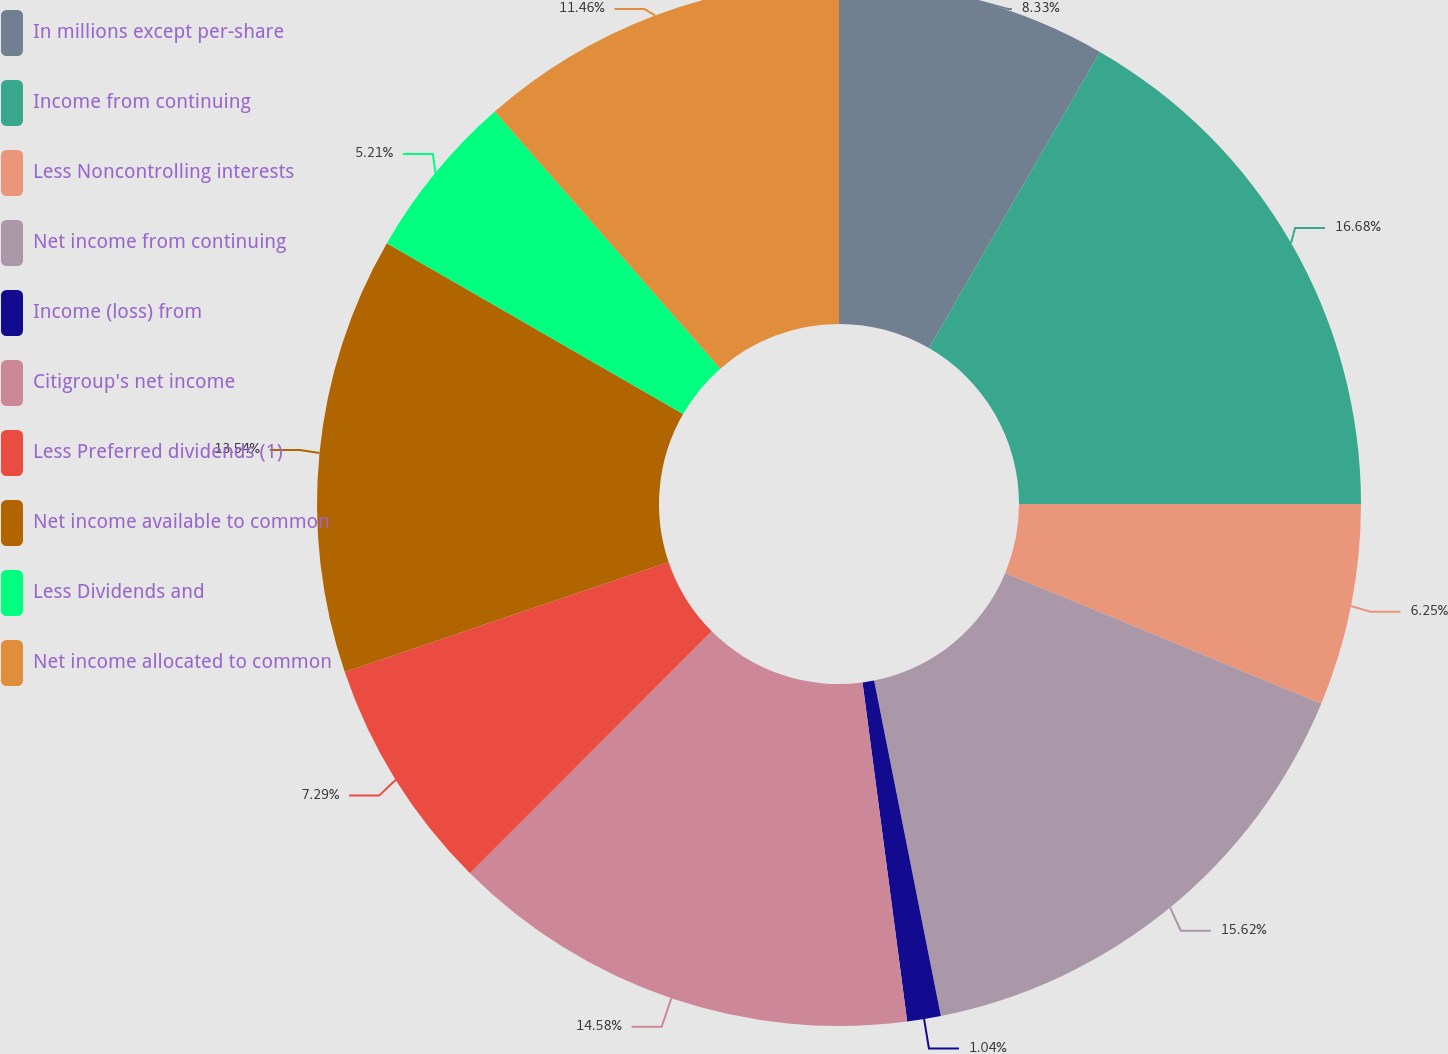Convert chart. <chart><loc_0><loc_0><loc_500><loc_500><pie_chart><fcel>In millions except per-share<fcel>Income from continuing<fcel>Less Noncontrolling interests<fcel>Net income from continuing<fcel>Income (loss) from<fcel>Citigroup's net income<fcel>Less Preferred dividends (1)<fcel>Net income available to common<fcel>Less Dividends and<fcel>Net income allocated to common<nl><fcel>8.33%<fcel>16.67%<fcel>6.25%<fcel>15.62%<fcel>1.04%<fcel>14.58%<fcel>7.29%<fcel>13.54%<fcel>5.21%<fcel>11.46%<nl></chart> 